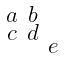Convert formula to latex. <formula><loc_0><loc_0><loc_500><loc_500>\begin{smallmatrix} a & b & \\ c & d & \\ & & e \end{smallmatrix}</formula> 